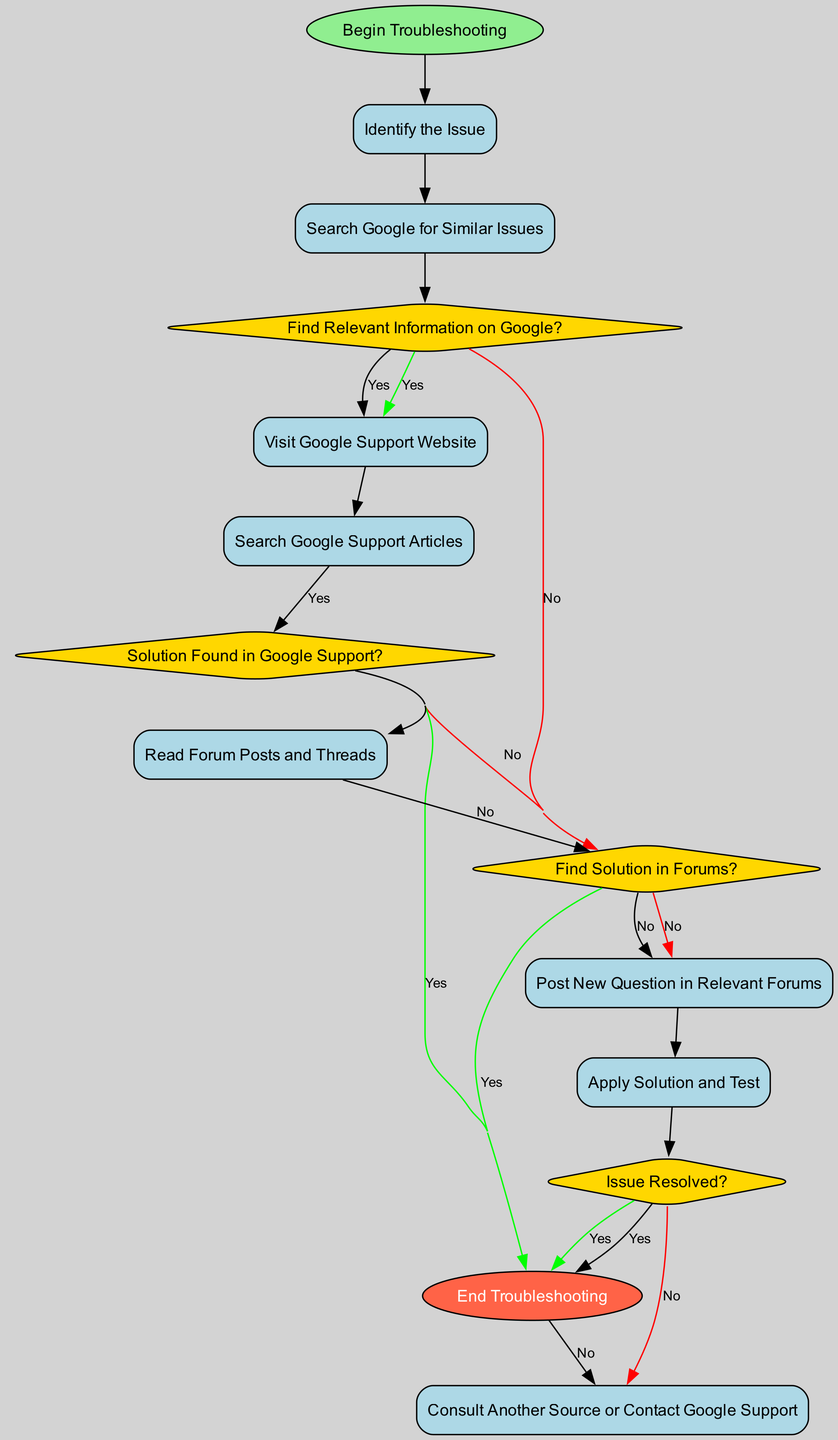What is the first action in the diagram? The first action is "Identify the Issue," which follows the "Begin Troubleshooting" start node in the flow of the diagram.
Answer: Identify the Issue How many decision nodes are present in the diagram? There are four decision nodes in the diagram: "Find Relevant Information on Google?", "Solution Found in Google Support?", "Find Solution in Forums?", and "Issue Resolved?".
Answer: 4 What happens if the solution is not found in Google Support? If the solution is not found in Google Support, the action taken is "Read Forum Posts and Threads," which is the next step if the answer to "Solution Found in Google Support?" is "No."
Answer: Read Forum Posts and Threads Which node concludes the troubleshooting process? The troubleshooting process concludes at the "End Troubleshooting" node, which is reached if the answer to "Issue Resolved?" is "Yes."
Answer: End Troubleshooting In what case would a user consult another source or contact Google support? A user would consult another source or contact Google support if the answer to "Issue Resolved?" is "No," indicating that the issue is still present after attempts to find a solution.
Answer: Consult Another Source or Contact Google Support What is the action taken after reading forum posts if no solution is found? After reading forum posts, if no solution is found, the action taken is "Post New Question in Relevant Forums." This action is specified for the condition "No" of the "Find Solution in Forums?" decision node.
Answer: Post New Question in Relevant Forums How many actions are there in total? The total number of actions in the diagram is seven, which includes "Identify the Issue," "Search Google for Similar Issues," "Visit Google Support Website," "Search Google Support Articles," "Read Forum Posts and Threads," "Apply Solution and Test," and "Post New Question in Relevant Forums."
Answer: 7 What should a user do if they find relevant information on Google? If a user finds relevant information on Google, the next action is to "Visit Google Support Website," which follows the positive outcome of the decision node "Find Relevant Information on Google?"
Answer: Visit Google Support Website What is the shape of the start node in the diagram? The shape of the start node in the diagram is oval, which is commonly used to represent the starting point in an activity diagram.
Answer: oval 